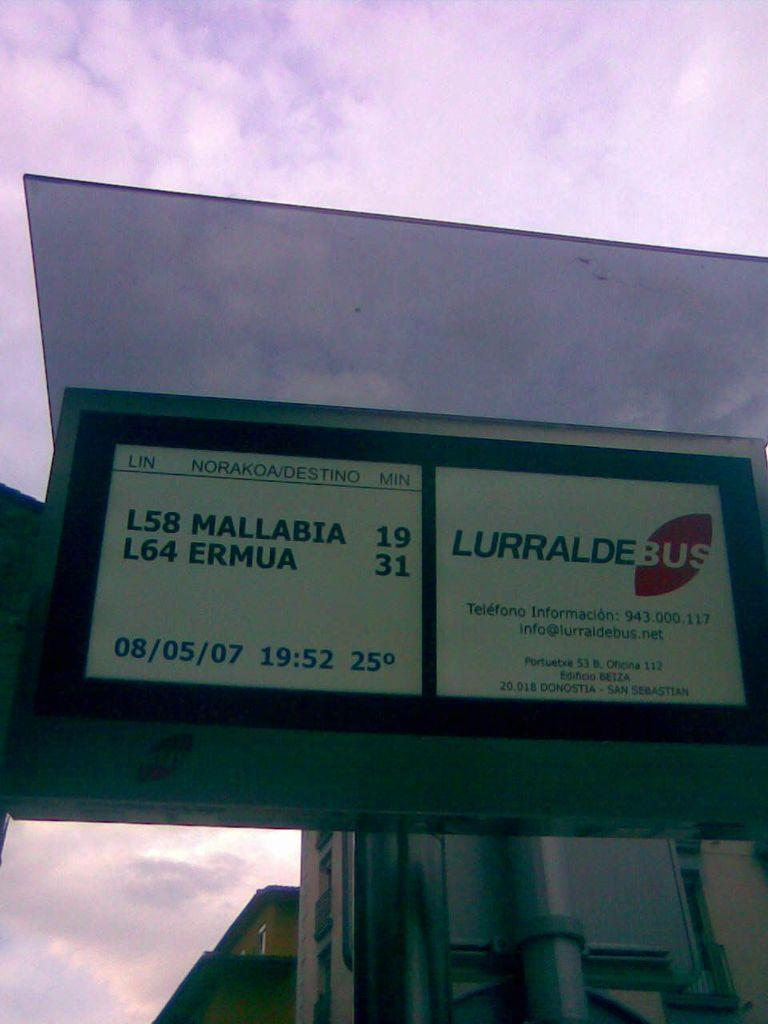<image>
Relay a brief, clear account of the picture shown. A white sine reads "L58 MALLABIA 19" and "LURRALDEBUS". 